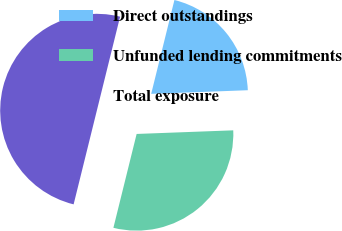<chart> <loc_0><loc_0><loc_500><loc_500><pie_chart><fcel>Direct outstandings<fcel>Unfunded lending commitments<fcel>Total exposure<nl><fcel>20.54%<fcel>29.46%<fcel>50.0%<nl></chart> 